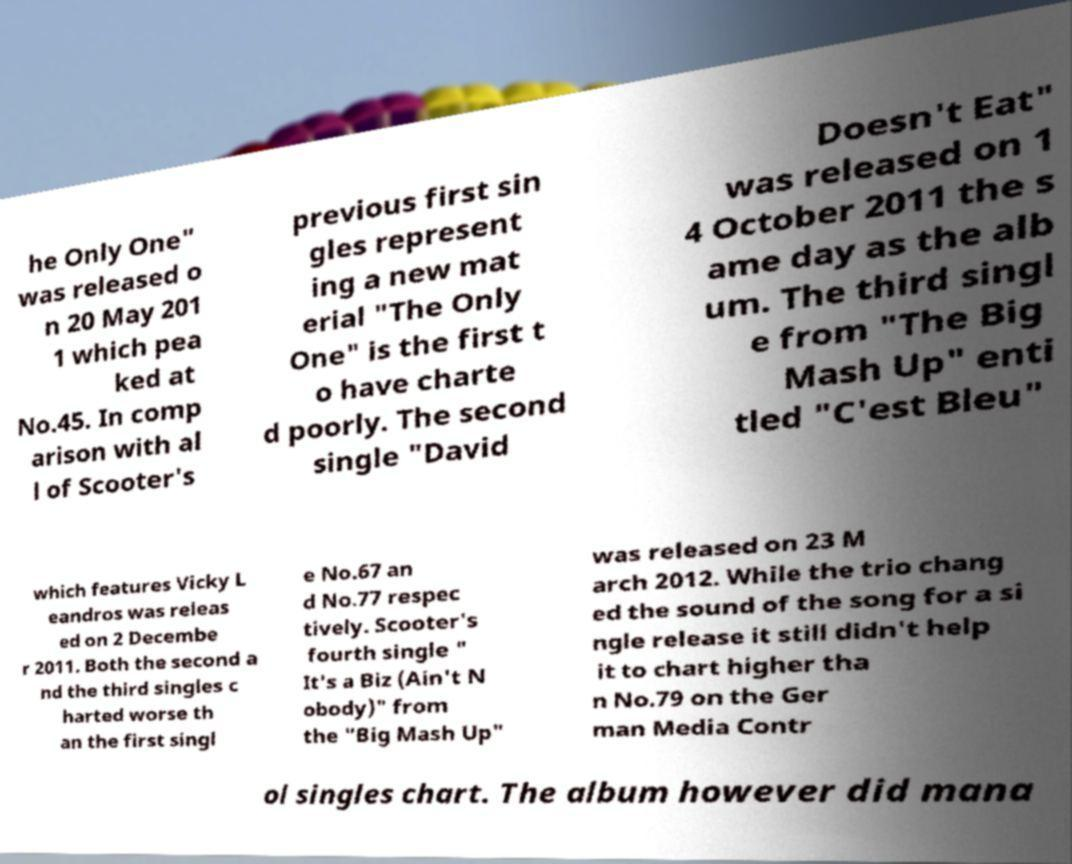Please identify and transcribe the text found in this image. he Only One" was released o n 20 May 201 1 which pea ked at No.45. In comp arison with al l of Scooter's previous first sin gles represent ing a new mat erial "The Only One" is the first t o have charte d poorly. The second single "David Doesn't Eat" was released on 1 4 October 2011 the s ame day as the alb um. The third singl e from "The Big Mash Up" enti tled "C'est Bleu" which features Vicky L eandros was releas ed on 2 Decembe r 2011. Both the second a nd the third singles c harted worse th an the first singl e No.67 an d No.77 respec tively. Scooter's fourth single " It's a Biz (Ain't N obody)" from the "Big Mash Up" was released on 23 M arch 2012. While the trio chang ed the sound of the song for a si ngle release it still didn't help it to chart higher tha n No.79 on the Ger man Media Contr ol singles chart. The album however did mana 